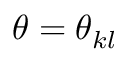<formula> <loc_0><loc_0><loc_500><loc_500>\theta = \theta _ { k l }</formula> 